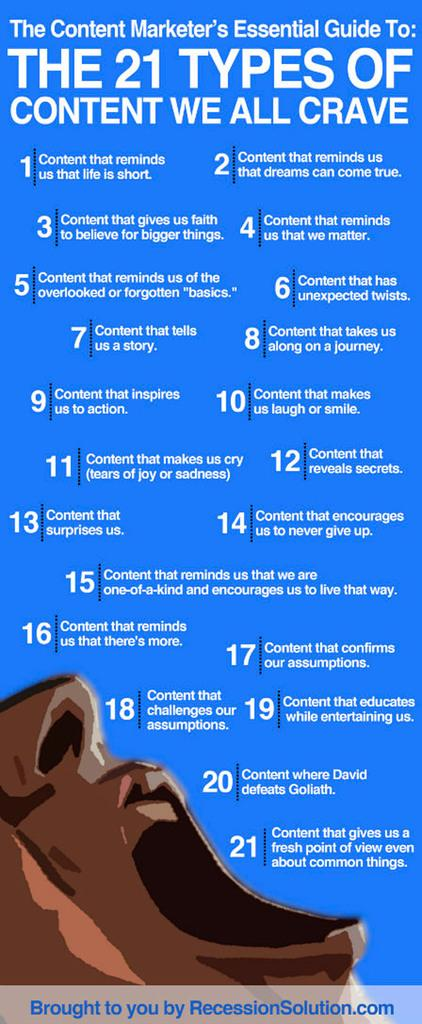What type of character is in the image? There is a cartoon person in the image. What else can be seen on the image besides the cartoon person? There is text written on the image. What color is the background of the image? The background of the image is blue. What type of discovery was made by the men in the image? There are no men or any indication of a discovery in the image; it features a cartoon person and text on a blue background. 